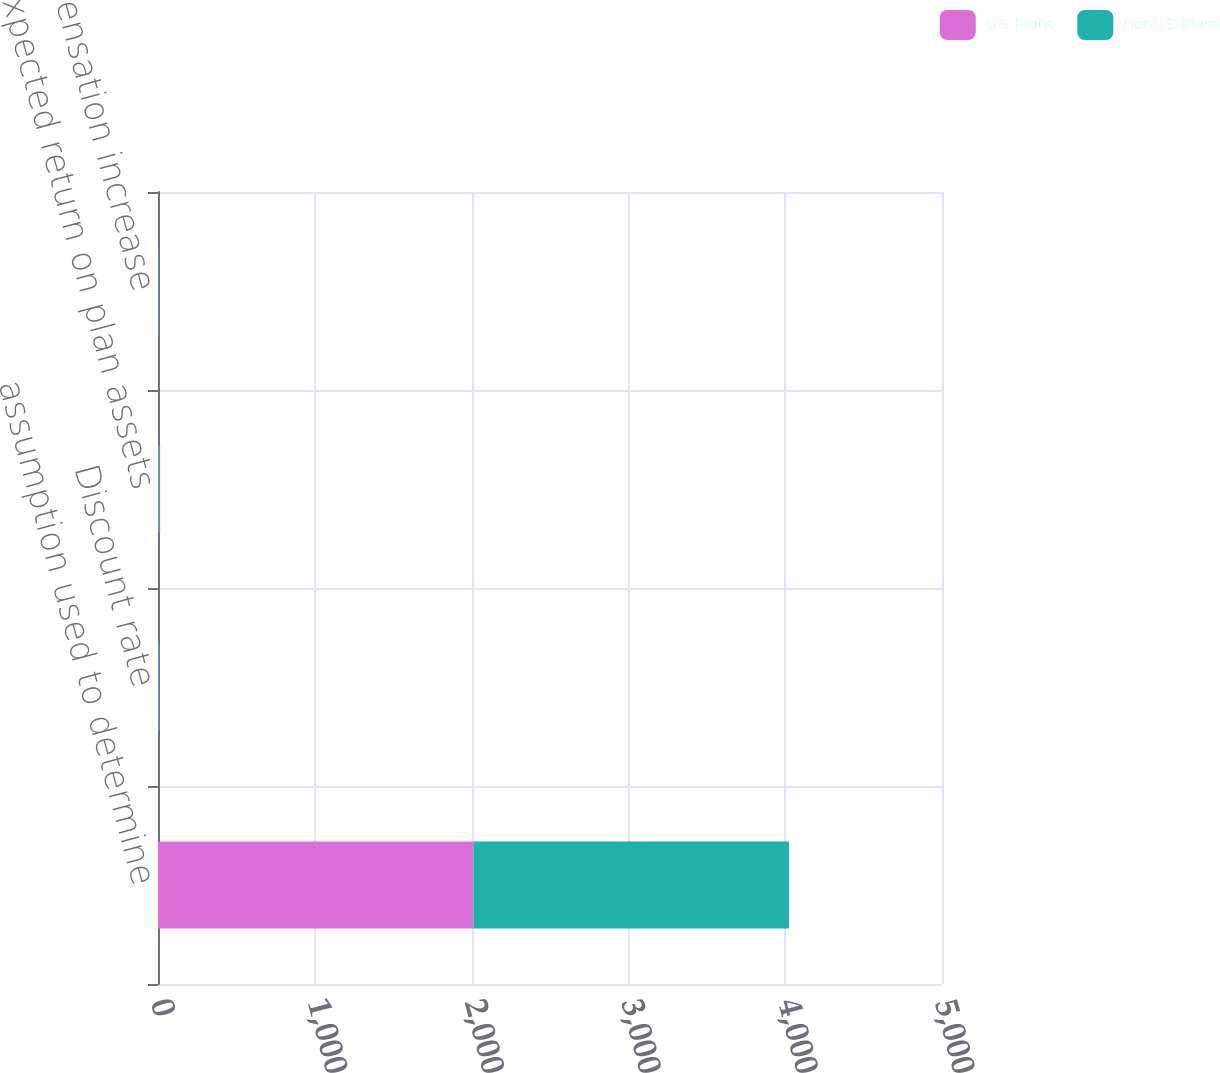Convert chart to OTSL. <chart><loc_0><loc_0><loc_500><loc_500><stacked_bar_chart><ecel><fcel>assumption used to determine<fcel>Discount rate<fcel>Expected return on plan assets<fcel>Rate of compensation increase<nl><fcel>U.S. Plans<fcel>2012<fcel>4.7<fcel>7.3<fcel>3.25<nl><fcel>NonU.S. Plans<fcel>2012<fcel>4.71<fcel>6.27<fcel>2.88<nl></chart> 